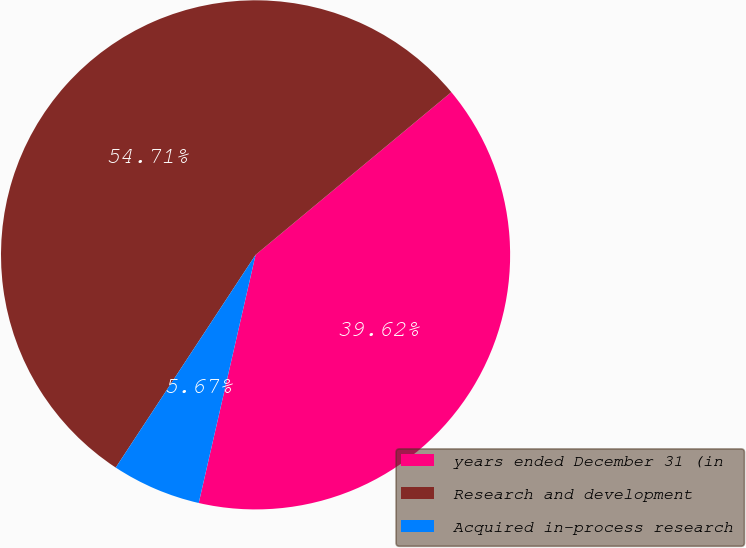Convert chart to OTSL. <chart><loc_0><loc_0><loc_500><loc_500><pie_chart><fcel>years ended December 31 (in<fcel>Research and development<fcel>Acquired in-process research<nl><fcel>39.62%<fcel>54.71%<fcel>5.67%<nl></chart> 